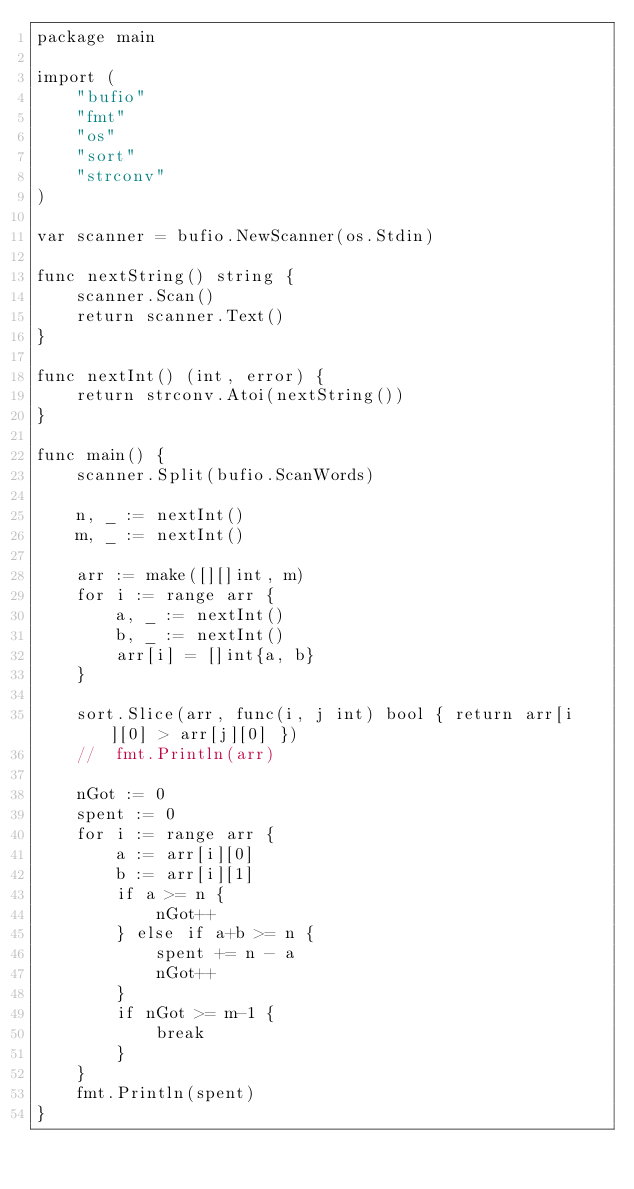<code> <loc_0><loc_0><loc_500><loc_500><_Go_>package main

import (
	"bufio"
	"fmt"
	"os"
	"sort"
	"strconv"
)

var scanner = bufio.NewScanner(os.Stdin)

func nextString() string {
	scanner.Scan()
	return scanner.Text()
}

func nextInt() (int, error) {
	return strconv.Atoi(nextString())
}

func main() {
	scanner.Split(bufio.ScanWords)

	n, _ := nextInt()
	m, _ := nextInt()

	arr := make([][]int, m)
	for i := range arr {
		a, _ := nextInt()
		b, _ := nextInt()
		arr[i] = []int{a, b}
	}

	sort.Slice(arr, func(i, j int) bool { return arr[i][0] > arr[j][0] })
	//	fmt.Println(arr)

	nGot := 0
	spent := 0
	for i := range arr {
		a := arr[i][0]
		b := arr[i][1]
		if a >= n {
			nGot++
		} else if a+b >= n {
			spent += n - a
			nGot++
		}
		if nGot >= m-1 {
			break
		}
	}
	fmt.Println(spent)
}

</code> 